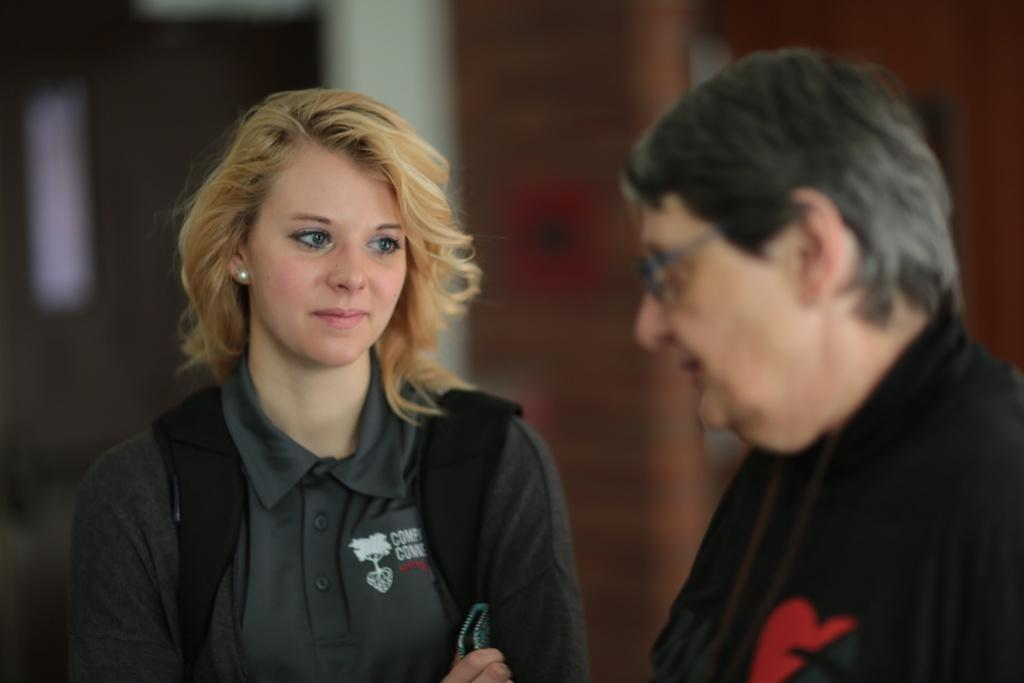What is the main subject of the image? There is a woman in the image. What is the woman doing in the image? The woman is standing and looking sideways. What is the woman's facial expression in the image? The woman is smiling in the image. What is the woman wearing in the image? The woman is wearing a bag. Are there any other people in the image? Yes, there is another person in the image. What is the other person wearing in the image? The other person is wearing a black dress. Can you tell me how many bushes are in the image? There are no bushes present in the image. Is the woman in the image a beginner at smiling? The image does not provide information about the woman's experience with smiling, so it cannot be determined from the image. 